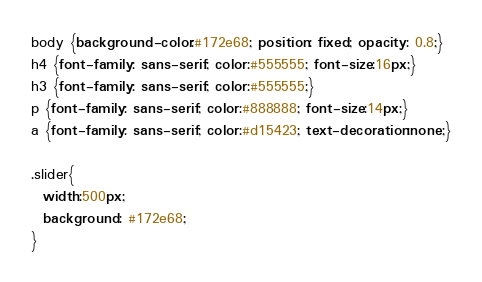<code> <loc_0><loc_0><loc_500><loc_500><_CSS_>body {background-color:#172e68; position: fixed; opacity: 0.8;} 
h4 {font-family: sans-serif; color:#555555; font-size:16px;}
h3 {font-family: sans-serif; color:#555555;}
p {font-family: sans-serif; color:#888888; font-size:14px;}
a {font-family: sans-serif; color:#d15423; text-decoration:none;}

.slider{
  width:500px;
  background: #172e68;
}


</code> 